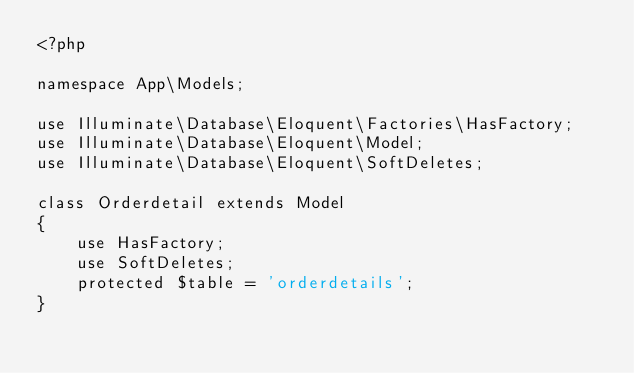<code> <loc_0><loc_0><loc_500><loc_500><_PHP_><?php

namespace App\Models;

use Illuminate\Database\Eloquent\Factories\HasFactory;
use Illuminate\Database\Eloquent\Model;
use Illuminate\Database\Eloquent\SoftDeletes;

class Orderdetail extends Model
{
    use HasFactory;
    use SoftDeletes;
    protected $table = 'orderdetails';
}
</code> 